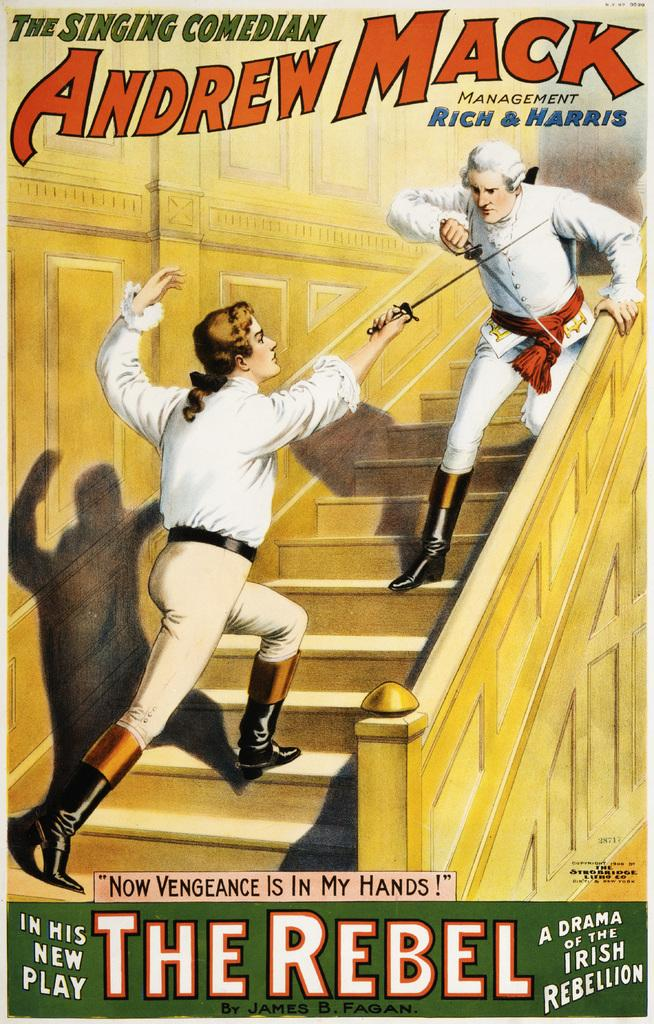<image>
Render a clear and concise summary of the photo. a poster with the title of The Rebel on it 